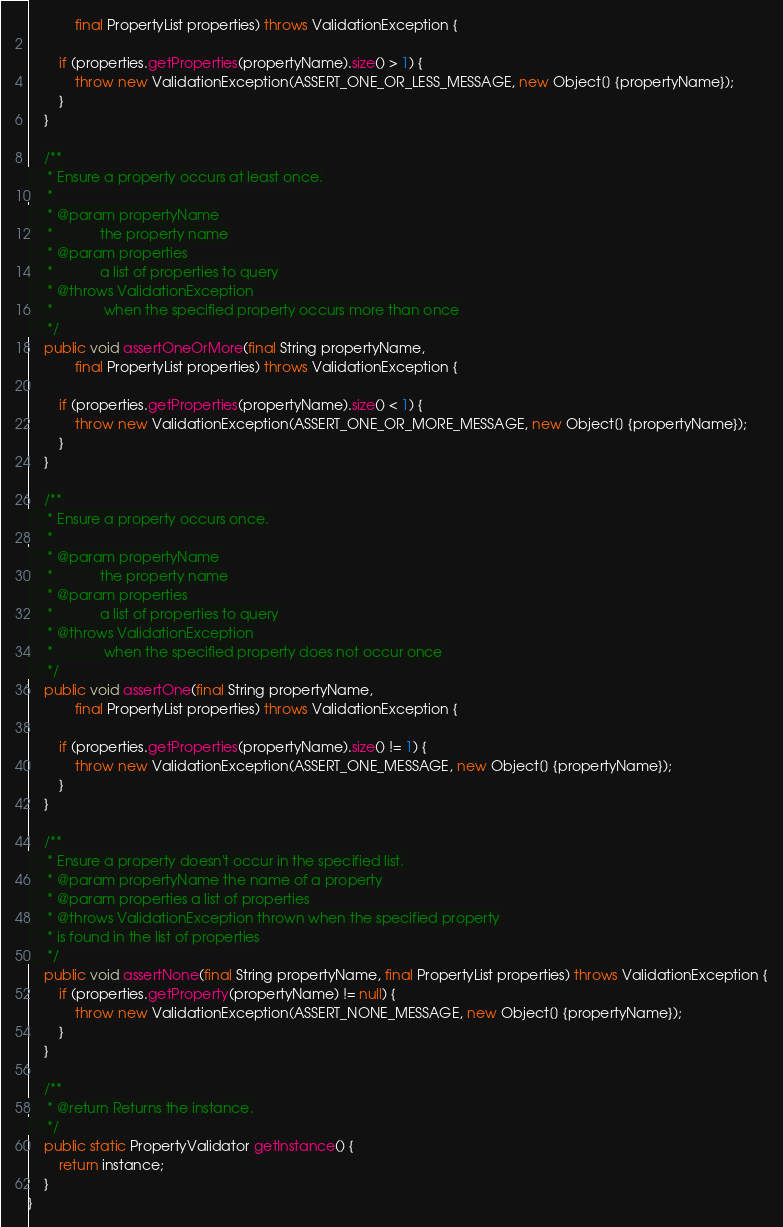Convert code to text. <code><loc_0><loc_0><loc_500><loc_500><_Java_>            final PropertyList properties) throws ValidationException {

        if (properties.getProperties(propertyName).size() > 1) {
            throw new ValidationException(ASSERT_ONE_OR_LESS_MESSAGE, new Object[] {propertyName});
        }
    }

    /**
     * Ensure a property occurs at least once.
     *
     * @param propertyName
     *            the property name
     * @param properties
     *            a list of properties to query
     * @throws ValidationException
     *             when the specified property occurs more than once
     */
    public void assertOneOrMore(final String propertyName,
            final PropertyList properties) throws ValidationException {

        if (properties.getProperties(propertyName).size() < 1) {
            throw new ValidationException(ASSERT_ONE_OR_MORE_MESSAGE, new Object[] {propertyName});
        }
    }

    /**
     * Ensure a property occurs once.
     *
     * @param propertyName
     *            the property name
     * @param properties
     *            a list of properties to query
     * @throws ValidationException
     *             when the specified property does not occur once
     */
    public void assertOne(final String propertyName,
            final PropertyList properties) throws ValidationException {

        if (properties.getProperties(propertyName).size() != 1) {
            throw new ValidationException(ASSERT_ONE_MESSAGE, new Object[] {propertyName});
        }
    }
    
    /**
     * Ensure a property doesn't occur in the specified list.
     * @param propertyName the name of a property
     * @param properties a list of properties
     * @throws ValidationException thrown when the specified property
     * is found in the list of properties
     */
    public void assertNone(final String propertyName, final PropertyList properties) throws ValidationException {
        if (properties.getProperty(propertyName) != null) {
            throw new ValidationException(ASSERT_NONE_MESSAGE, new Object[] {propertyName});
        }
    }

    /**
     * @return Returns the instance.
     */
    public static PropertyValidator getInstance() {
        return instance;
    }
}
</code> 